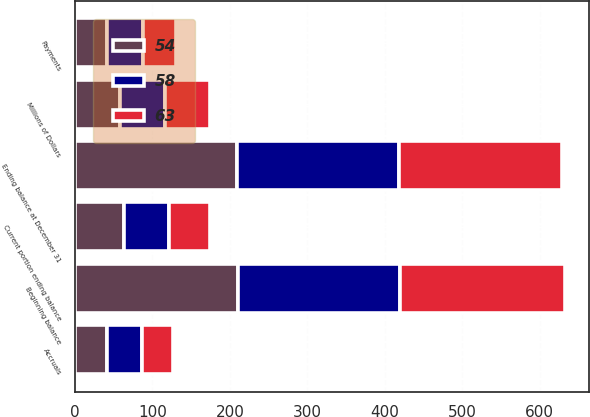<chart> <loc_0><loc_0><loc_500><loc_500><stacked_bar_chart><ecel><fcel>Millions of Dollars<fcel>Beginning balance<fcel>Accruals<fcel>Payments<fcel>Ending balance at December 31<fcel>Current portion ending balance<nl><fcel>58<fcel>58<fcel>209<fcel>46<fcel>46<fcel>209<fcel>58<nl><fcel>54<fcel>58<fcel>210<fcel>41<fcel>42<fcel>209<fcel>63<nl><fcel>63<fcel>58<fcel>213<fcel>39<fcel>42<fcel>210<fcel>54<nl></chart> 